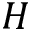<formula> <loc_0><loc_0><loc_500><loc_500>H</formula> 